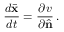Convert formula to latex. <formula><loc_0><loc_0><loc_500><loc_500>\frac { d \bar { x } } { d t } = \frac { \partial v } { \partial \hat { n } } \, .</formula> 